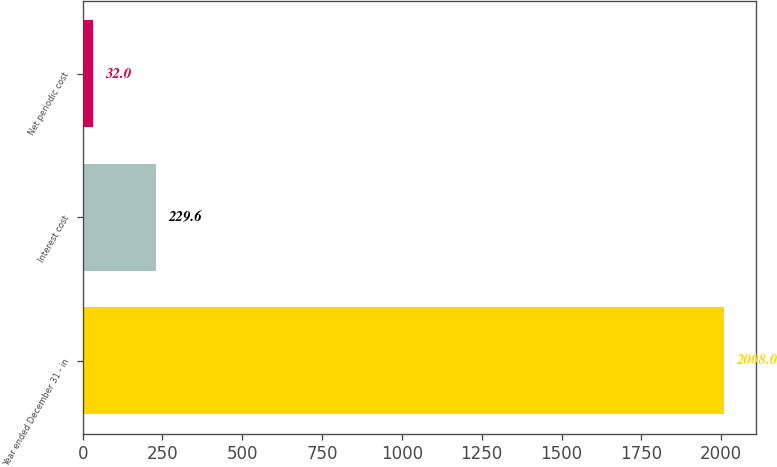<chart> <loc_0><loc_0><loc_500><loc_500><bar_chart><fcel>Year ended December 31 - in<fcel>Interest cost<fcel>Net periodic cost<nl><fcel>2008<fcel>229.6<fcel>32<nl></chart> 